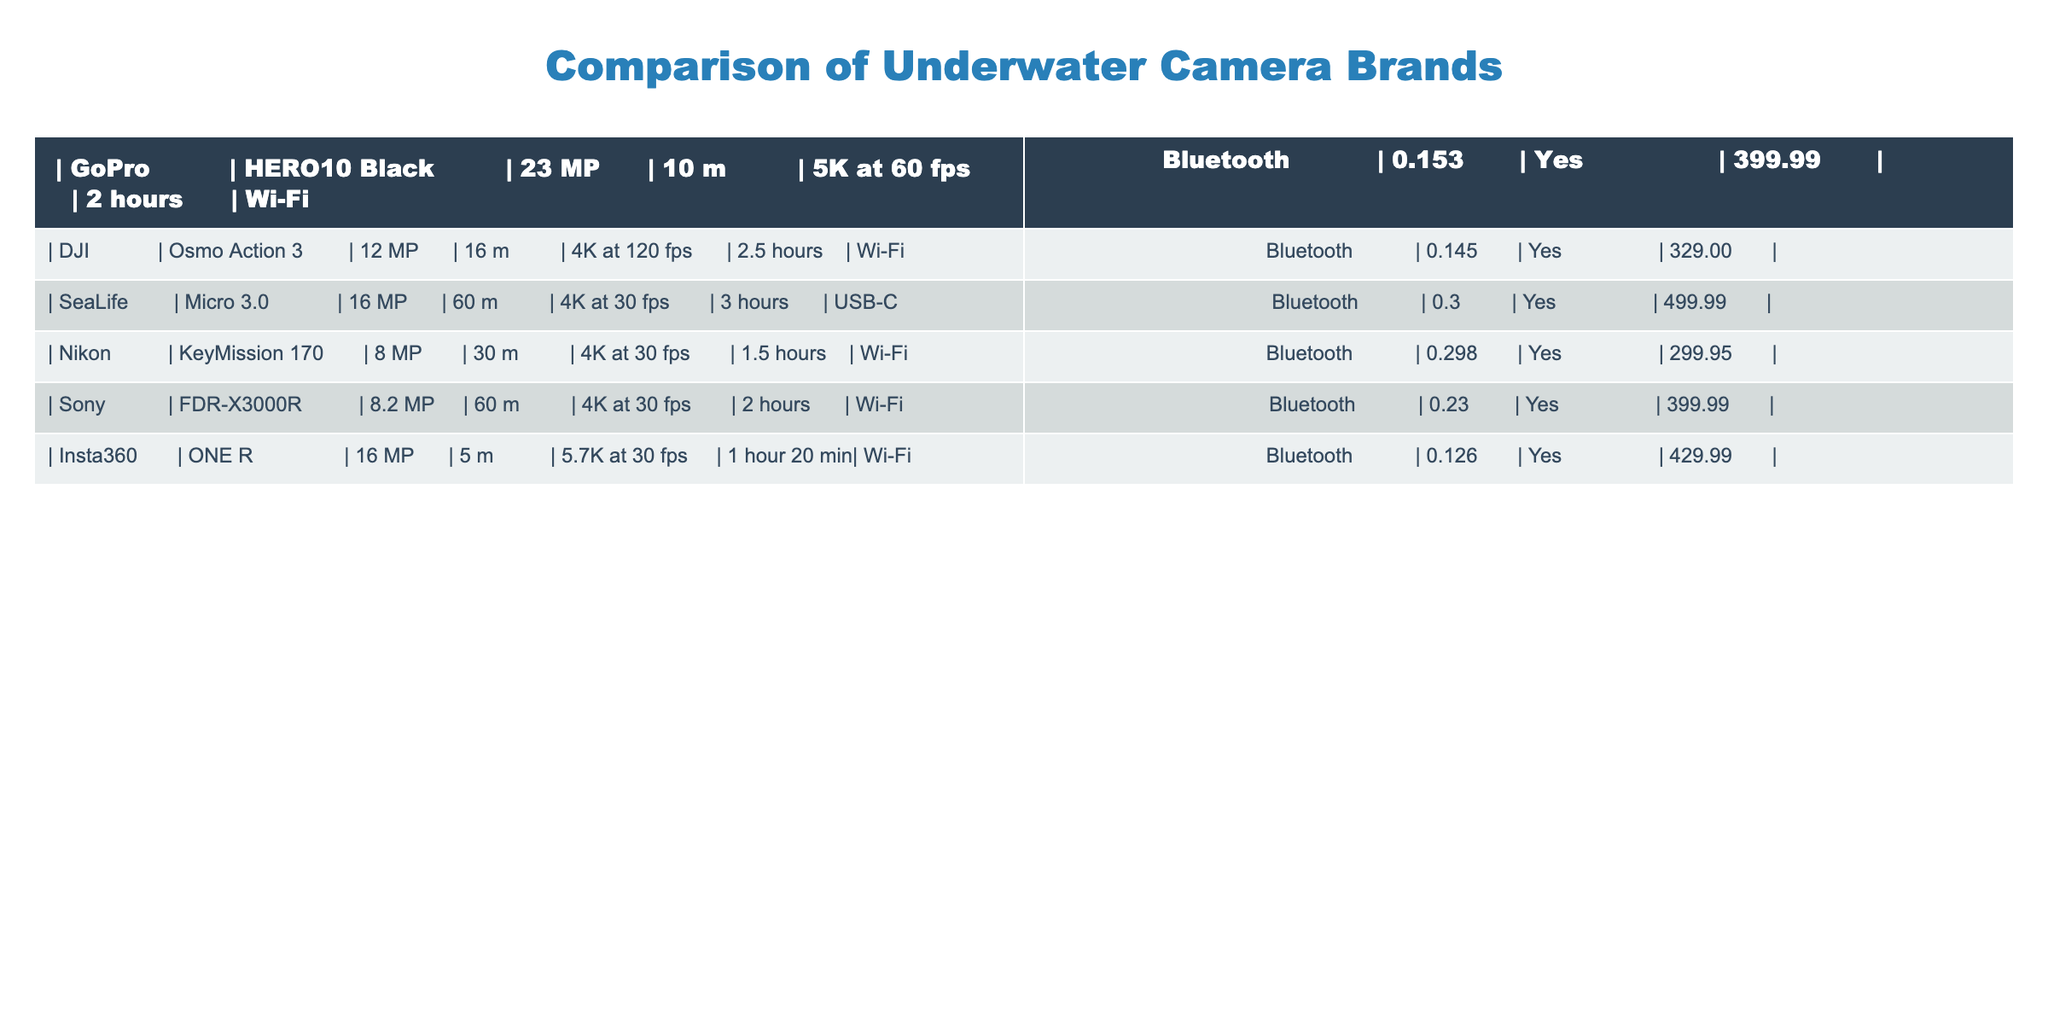What is the maximum depth rating among the listed cameras? The table shows the depth ratings for each camera, with SeaLife Micro 3.0 having the highest rating at 60 m.
Answer: 60 m Which camera has the best video resolution and frame rate? To determine the best video resolution and frame rate, we compare the specifications: GoPro HERO10 Black can record in 5K at 60 fps, which is higher than the other cameras' capabilities.
Answer: GoPro HERO10 Black How many cameras can record 4K video? By looking at the table, we see that five cameras—DJI Osmo Action 3, SeaLife Micro 3.0, Nikon KeyMission 170, Sony FDR-X3000R, and Insta360 ONE R—can record 4K video.
Answer: 5 cameras What is the price difference between the highest and lowest-priced cameras? The highest-priced camera is SeaLife Micro 3.0 at $499.99, and the lowest is Nikon KeyMission 170 at $299.95. Calculating the difference: $499.99 - $299.95 = $200.04.
Answer: $200.04 Which camera has the longest battery life? Checking the battery life values in the table, SeaLife Micro 3.0 has the longest battery life at 3 hours.
Answer: SeaLife Micro 3.0 Is there any camera that has a resolution higher than 20 MP? Upon reviewing the specifications, both the GoPro HERO10 Black and SeaLife Micro 3.0 have resolutions of 23 MP and 16 MP, respectively, making only the GoPro HERO10 output higher than 20 MP.
Answer: Yes How does the average megapixel of these cameras compare to the median? First, we calculate the average: (23 + 12 + 16 + 8 + 8.2 + 16) / 6 = 15.7. For the median, the sorted resolutions are: 8, 8.2, 12, 16, 16, 23. Thus, the median is (12 + 16) / 2 = 14. The average (15.7) is slightly higher than the median (14).
Answer: Average is higher than median Are all cameras equipped with Wi-Fi and Bluetooth? Reviewing the connectivity features across all cameras in the table, they all have either Wi-Fi or Bluetooth capability.
Answer: Yes Which camera is the lightest among those listed? The weights are compared, and DJI Osmo Action 3 is the lightest at 0.145 kg, while others are heavier.
Answer: DJI Osmo Action 3 What is the total weight of all listed cameras? Adding up all weights: 0.153 + 0.145 + 0.3 + 0.298 + 0.23 + 0.126 = 1.252 kg gives the total weight of the cameras.
Answer: 1.252 kg 